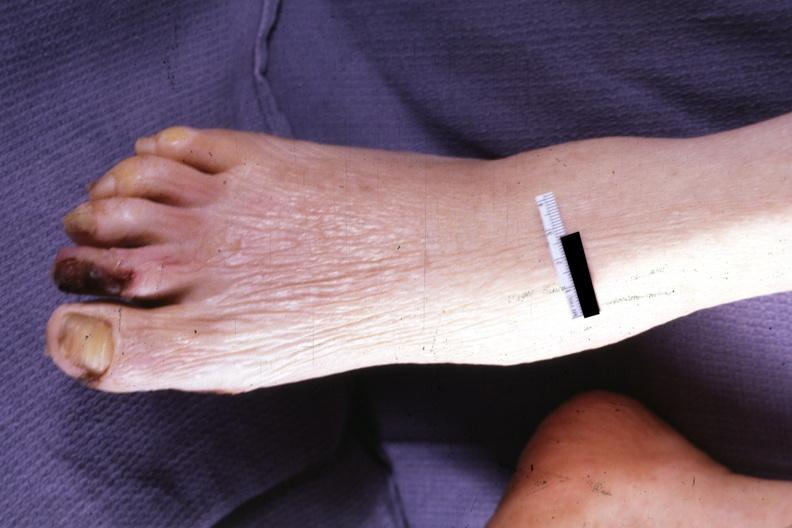does this image show typical small lesion?
Answer the question using a single word or phrase. Yes 